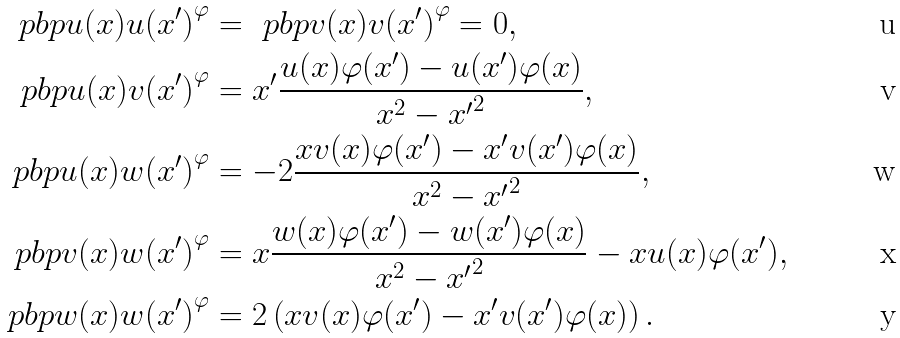Convert formula to latex. <formula><loc_0><loc_0><loc_500><loc_500>\ p b p { u ( x ) } { u ( x ^ { \prime } ) } ^ { \varphi } & = \ p b p { v ( x ) } { v ( x ^ { \prime } ) } ^ { \varphi } = 0 , \\ \ p b p { u ( x ) } { v ( x ^ { \prime } ) } ^ { \varphi } & = x ^ { \prime } \frac { u ( x ) \varphi ( x ^ { \prime } ) - u ( x ^ { \prime } ) \varphi ( x ) } { x ^ { 2 } - { x ^ { \prime } } ^ { 2 } } , \\ \ p b p { u ( x ) } { w ( x ^ { \prime } ) } ^ { \varphi } & = - 2 \frac { x v ( x ) \varphi ( x ^ { \prime } ) - x ^ { \prime } v ( x ^ { \prime } ) \varphi ( x ) } { x ^ { 2 } - { x ^ { \prime } } ^ { 2 } } , \\ \ p b p { v ( x ) } { w ( x ^ { \prime } ) } ^ { \varphi } & = x \frac { w ( x ) \varphi ( x ^ { \prime } ) - w ( x ^ { \prime } ) \varphi ( x ) } { x ^ { 2 } - { x ^ { \prime } } ^ { 2 } } - x u ( x ) \varphi ( x ^ { \prime } ) , \\ \ p b p { w ( x ) } { w ( x ^ { \prime } ) } ^ { \varphi } & = 2 \left ( x v ( x ) \varphi ( x ^ { \prime } ) - x ^ { \prime } v ( x ^ { \prime } ) \varphi ( x ) \right ) .</formula> 